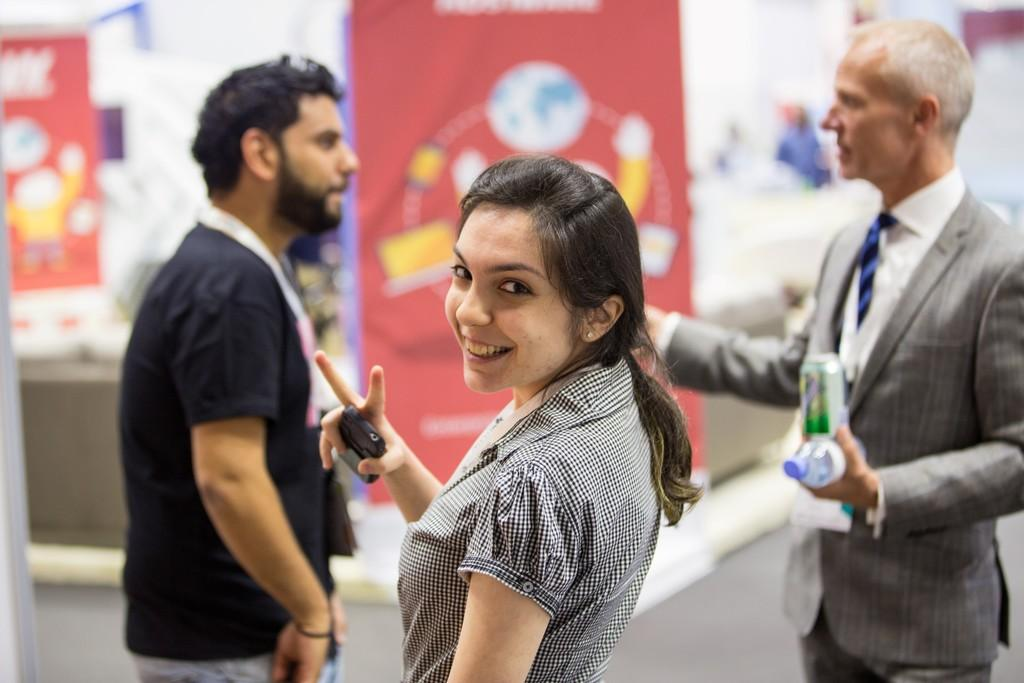What is present in the image? There are people standing in the image. Where are the rabbits hiding in the image? There are no rabbits present in the image. What type of car can be seen in the image? There is no car present in the image. 